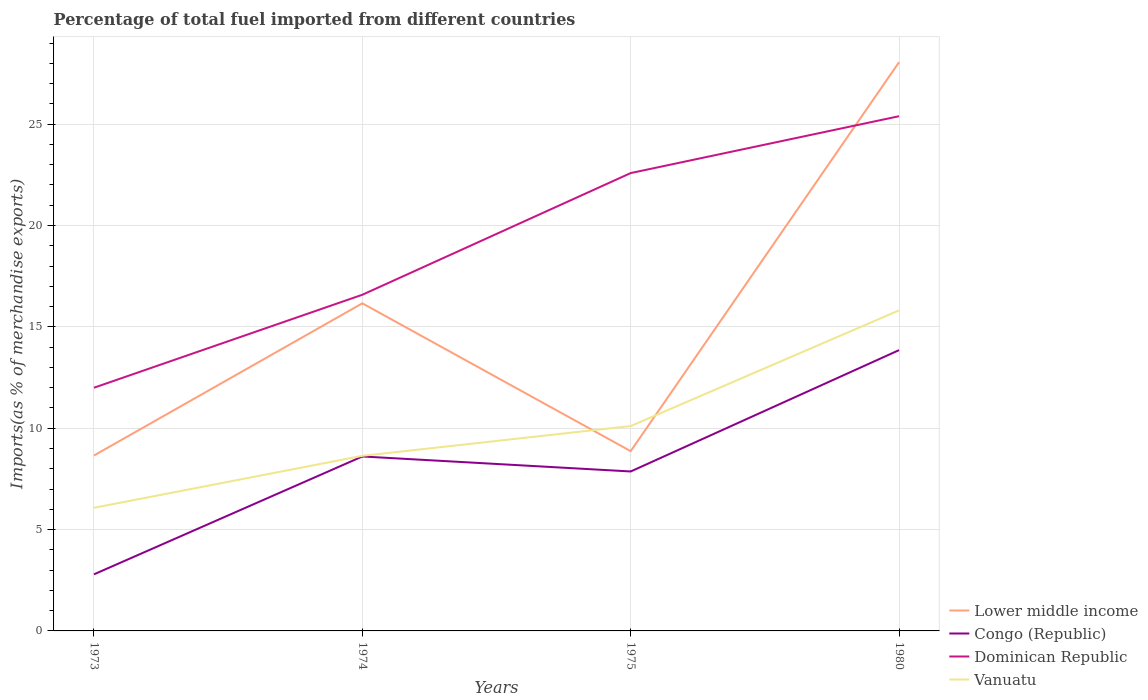How many different coloured lines are there?
Your answer should be very brief. 4. Is the number of lines equal to the number of legend labels?
Your response must be concise. Yes. Across all years, what is the maximum percentage of imports to different countries in Vanuatu?
Make the answer very short. 6.07. What is the total percentage of imports to different countries in Vanuatu in the graph?
Offer a terse response. -2.56. What is the difference between the highest and the second highest percentage of imports to different countries in Vanuatu?
Provide a succinct answer. 9.74. How many lines are there?
Provide a succinct answer. 4. What is the difference between two consecutive major ticks on the Y-axis?
Offer a very short reply. 5. Are the values on the major ticks of Y-axis written in scientific E-notation?
Provide a succinct answer. No. Does the graph contain any zero values?
Your response must be concise. No. Where does the legend appear in the graph?
Keep it short and to the point. Bottom right. How are the legend labels stacked?
Offer a very short reply. Vertical. What is the title of the graph?
Your answer should be very brief. Percentage of total fuel imported from different countries. Does "New Caledonia" appear as one of the legend labels in the graph?
Your response must be concise. No. What is the label or title of the X-axis?
Offer a very short reply. Years. What is the label or title of the Y-axis?
Make the answer very short. Imports(as % of merchandise exports). What is the Imports(as % of merchandise exports) of Lower middle income in 1973?
Provide a short and direct response. 8.65. What is the Imports(as % of merchandise exports) in Congo (Republic) in 1973?
Make the answer very short. 2.79. What is the Imports(as % of merchandise exports) of Dominican Republic in 1973?
Your answer should be very brief. 12. What is the Imports(as % of merchandise exports) of Vanuatu in 1973?
Keep it short and to the point. 6.07. What is the Imports(as % of merchandise exports) in Lower middle income in 1974?
Make the answer very short. 16.16. What is the Imports(as % of merchandise exports) in Congo (Republic) in 1974?
Your response must be concise. 8.61. What is the Imports(as % of merchandise exports) in Dominican Republic in 1974?
Offer a terse response. 16.58. What is the Imports(as % of merchandise exports) in Vanuatu in 1974?
Your answer should be very brief. 8.64. What is the Imports(as % of merchandise exports) of Lower middle income in 1975?
Ensure brevity in your answer.  8.87. What is the Imports(as % of merchandise exports) in Congo (Republic) in 1975?
Your answer should be very brief. 7.86. What is the Imports(as % of merchandise exports) of Dominican Republic in 1975?
Your answer should be compact. 22.58. What is the Imports(as % of merchandise exports) of Vanuatu in 1975?
Provide a short and direct response. 10.1. What is the Imports(as % of merchandise exports) in Lower middle income in 1980?
Offer a terse response. 28.05. What is the Imports(as % of merchandise exports) in Congo (Republic) in 1980?
Provide a short and direct response. 13.85. What is the Imports(as % of merchandise exports) in Dominican Republic in 1980?
Your answer should be very brief. 25.39. What is the Imports(as % of merchandise exports) in Vanuatu in 1980?
Offer a terse response. 15.81. Across all years, what is the maximum Imports(as % of merchandise exports) in Lower middle income?
Ensure brevity in your answer.  28.05. Across all years, what is the maximum Imports(as % of merchandise exports) in Congo (Republic)?
Make the answer very short. 13.85. Across all years, what is the maximum Imports(as % of merchandise exports) of Dominican Republic?
Offer a terse response. 25.39. Across all years, what is the maximum Imports(as % of merchandise exports) in Vanuatu?
Keep it short and to the point. 15.81. Across all years, what is the minimum Imports(as % of merchandise exports) of Lower middle income?
Offer a very short reply. 8.65. Across all years, what is the minimum Imports(as % of merchandise exports) in Congo (Republic)?
Offer a terse response. 2.79. Across all years, what is the minimum Imports(as % of merchandise exports) in Dominican Republic?
Provide a succinct answer. 12. Across all years, what is the minimum Imports(as % of merchandise exports) in Vanuatu?
Your answer should be very brief. 6.07. What is the total Imports(as % of merchandise exports) in Lower middle income in the graph?
Your response must be concise. 61.73. What is the total Imports(as % of merchandise exports) of Congo (Republic) in the graph?
Keep it short and to the point. 33.11. What is the total Imports(as % of merchandise exports) of Dominican Republic in the graph?
Your response must be concise. 76.55. What is the total Imports(as % of merchandise exports) in Vanuatu in the graph?
Make the answer very short. 40.63. What is the difference between the Imports(as % of merchandise exports) of Lower middle income in 1973 and that in 1974?
Provide a short and direct response. -7.51. What is the difference between the Imports(as % of merchandise exports) in Congo (Republic) in 1973 and that in 1974?
Your answer should be compact. -5.81. What is the difference between the Imports(as % of merchandise exports) of Dominican Republic in 1973 and that in 1974?
Provide a succinct answer. -4.59. What is the difference between the Imports(as % of merchandise exports) in Vanuatu in 1973 and that in 1974?
Offer a very short reply. -2.56. What is the difference between the Imports(as % of merchandise exports) of Lower middle income in 1973 and that in 1975?
Provide a succinct answer. -0.22. What is the difference between the Imports(as % of merchandise exports) of Congo (Republic) in 1973 and that in 1975?
Provide a short and direct response. -5.07. What is the difference between the Imports(as % of merchandise exports) in Dominican Republic in 1973 and that in 1975?
Keep it short and to the point. -10.59. What is the difference between the Imports(as % of merchandise exports) in Vanuatu in 1973 and that in 1975?
Provide a short and direct response. -4.03. What is the difference between the Imports(as % of merchandise exports) in Lower middle income in 1973 and that in 1980?
Your response must be concise. -19.4. What is the difference between the Imports(as % of merchandise exports) in Congo (Republic) in 1973 and that in 1980?
Ensure brevity in your answer.  -11.06. What is the difference between the Imports(as % of merchandise exports) in Dominican Republic in 1973 and that in 1980?
Keep it short and to the point. -13.39. What is the difference between the Imports(as % of merchandise exports) in Vanuatu in 1973 and that in 1980?
Provide a succinct answer. -9.74. What is the difference between the Imports(as % of merchandise exports) of Lower middle income in 1974 and that in 1975?
Offer a terse response. 7.29. What is the difference between the Imports(as % of merchandise exports) in Congo (Republic) in 1974 and that in 1975?
Your response must be concise. 0.74. What is the difference between the Imports(as % of merchandise exports) in Dominican Republic in 1974 and that in 1975?
Give a very brief answer. -6. What is the difference between the Imports(as % of merchandise exports) of Vanuatu in 1974 and that in 1975?
Ensure brevity in your answer.  -1.47. What is the difference between the Imports(as % of merchandise exports) in Lower middle income in 1974 and that in 1980?
Keep it short and to the point. -11.89. What is the difference between the Imports(as % of merchandise exports) in Congo (Republic) in 1974 and that in 1980?
Ensure brevity in your answer.  -5.25. What is the difference between the Imports(as % of merchandise exports) in Dominican Republic in 1974 and that in 1980?
Offer a terse response. -8.81. What is the difference between the Imports(as % of merchandise exports) of Vanuatu in 1974 and that in 1980?
Offer a very short reply. -7.17. What is the difference between the Imports(as % of merchandise exports) in Lower middle income in 1975 and that in 1980?
Your answer should be compact. -19.19. What is the difference between the Imports(as % of merchandise exports) in Congo (Republic) in 1975 and that in 1980?
Offer a terse response. -5.99. What is the difference between the Imports(as % of merchandise exports) in Dominican Republic in 1975 and that in 1980?
Offer a terse response. -2.81. What is the difference between the Imports(as % of merchandise exports) of Vanuatu in 1975 and that in 1980?
Offer a terse response. -5.71. What is the difference between the Imports(as % of merchandise exports) of Lower middle income in 1973 and the Imports(as % of merchandise exports) of Congo (Republic) in 1974?
Make the answer very short. 0.05. What is the difference between the Imports(as % of merchandise exports) in Lower middle income in 1973 and the Imports(as % of merchandise exports) in Dominican Republic in 1974?
Ensure brevity in your answer.  -7.93. What is the difference between the Imports(as % of merchandise exports) in Lower middle income in 1973 and the Imports(as % of merchandise exports) in Vanuatu in 1974?
Provide a succinct answer. 0.02. What is the difference between the Imports(as % of merchandise exports) in Congo (Republic) in 1973 and the Imports(as % of merchandise exports) in Dominican Republic in 1974?
Your answer should be compact. -13.79. What is the difference between the Imports(as % of merchandise exports) in Congo (Republic) in 1973 and the Imports(as % of merchandise exports) in Vanuatu in 1974?
Provide a short and direct response. -5.85. What is the difference between the Imports(as % of merchandise exports) of Dominican Republic in 1973 and the Imports(as % of merchandise exports) of Vanuatu in 1974?
Keep it short and to the point. 3.36. What is the difference between the Imports(as % of merchandise exports) in Lower middle income in 1973 and the Imports(as % of merchandise exports) in Congo (Republic) in 1975?
Provide a short and direct response. 0.79. What is the difference between the Imports(as % of merchandise exports) in Lower middle income in 1973 and the Imports(as % of merchandise exports) in Dominican Republic in 1975?
Ensure brevity in your answer.  -13.93. What is the difference between the Imports(as % of merchandise exports) in Lower middle income in 1973 and the Imports(as % of merchandise exports) in Vanuatu in 1975?
Your answer should be compact. -1.45. What is the difference between the Imports(as % of merchandise exports) in Congo (Republic) in 1973 and the Imports(as % of merchandise exports) in Dominican Republic in 1975?
Offer a very short reply. -19.79. What is the difference between the Imports(as % of merchandise exports) of Congo (Republic) in 1973 and the Imports(as % of merchandise exports) of Vanuatu in 1975?
Offer a terse response. -7.31. What is the difference between the Imports(as % of merchandise exports) of Dominican Republic in 1973 and the Imports(as % of merchandise exports) of Vanuatu in 1975?
Keep it short and to the point. 1.89. What is the difference between the Imports(as % of merchandise exports) in Lower middle income in 1973 and the Imports(as % of merchandise exports) in Congo (Republic) in 1980?
Your answer should be compact. -5.2. What is the difference between the Imports(as % of merchandise exports) of Lower middle income in 1973 and the Imports(as % of merchandise exports) of Dominican Republic in 1980?
Your response must be concise. -16.74. What is the difference between the Imports(as % of merchandise exports) in Lower middle income in 1973 and the Imports(as % of merchandise exports) in Vanuatu in 1980?
Keep it short and to the point. -7.16. What is the difference between the Imports(as % of merchandise exports) in Congo (Republic) in 1973 and the Imports(as % of merchandise exports) in Dominican Republic in 1980?
Make the answer very short. -22.6. What is the difference between the Imports(as % of merchandise exports) of Congo (Republic) in 1973 and the Imports(as % of merchandise exports) of Vanuatu in 1980?
Keep it short and to the point. -13.02. What is the difference between the Imports(as % of merchandise exports) in Dominican Republic in 1973 and the Imports(as % of merchandise exports) in Vanuatu in 1980?
Provide a succinct answer. -3.81. What is the difference between the Imports(as % of merchandise exports) of Lower middle income in 1974 and the Imports(as % of merchandise exports) of Congo (Republic) in 1975?
Offer a terse response. 8.29. What is the difference between the Imports(as % of merchandise exports) in Lower middle income in 1974 and the Imports(as % of merchandise exports) in Dominican Republic in 1975?
Your answer should be very brief. -6.42. What is the difference between the Imports(as % of merchandise exports) of Lower middle income in 1974 and the Imports(as % of merchandise exports) of Vanuatu in 1975?
Your answer should be compact. 6.06. What is the difference between the Imports(as % of merchandise exports) in Congo (Republic) in 1974 and the Imports(as % of merchandise exports) in Dominican Republic in 1975?
Make the answer very short. -13.98. What is the difference between the Imports(as % of merchandise exports) in Congo (Republic) in 1974 and the Imports(as % of merchandise exports) in Vanuatu in 1975?
Your answer should be compact. -1.5. What is the difference between the Imports(as % of merchandise exports) of Dominican Republic in 1974 and the Imports(as % of merchandise exports) of Vanuatu in 1975?
Ensure brevity in your answer.  6.48. What is the difference between the Imports(as % of merchandise exports) of Lower middle income in 1974 and the Imports(as % of merchandise exports) of Congo (Republic) in 1980?
Offer a very short reply. 2.31. What is the difference between the Imports(as % of merchandise exports) in Lower middle income in 1974 and the Imports(as % of merchandise exports) in Dominican Republic in 1980?
Your response must be concise. -9.23. What is the difference between the Imports(as % of merchandise exports) in Lower middle income in 1974 and the Imports(as % of merchandise exports) in Vanuatu in 1980?
Your answer should be compact. 0.35. What is the difference between the Imports(as % of merchandise exports) in Congo (Republic) in 1974 and the Imports(as % of merchandise exports) in Dominican Republic in 1980?
Offer a terse response. -16.78. What is the difference between the Imports(as % of merchandise exports) of Congo (Republic) in 1974 and the Imports(as % of merchandise exports) of Vanuatu in 1980?
Offer a terse response. -7.21. What is the difference between the Imports(as % of merchandise exports) in Dominican Republic in 1974 and the Imports(as % of merchandise exports) in Vanuatu in 1980?
Offer a terse response. 0.77. What is the difference between the Imports(as % of merchandise exports) of Lower middle income in 1975 and the Imports(as % of merchandise exports) of Congo (Republic) in 1980?
Your answer should be very brief. -4.98. What is the difference between the Imports(as % of merchandise exports) in Lower middle income in 1975 and the Imports(as % of merchandise exports) in Dominican Republic in 1980?
Offer a very short reply. -16.52. What is the difference between the Imports(as % of merchandise exports) of Lower middle income in 1975 and the Imports(as % of merchandise exports) of Vanuatu in 1980?
Ensure brevity in your answer.  -6.94. What is the difference between the Imports(as % of merchandise exports) in Congo (Republic) in 1975 and the Imports(as % of merchandise exports) in Dominican Republic in 1980?
Ensure brevity in your answer.  -17.52. What is the difference between the Imports(as % of merchandise exports) of Congo (Republic) in 1975 and the Imports(as % of merchandise exports) of Vanuatu in 1980?
Your response must be concise. -7.95. What is the difference between the Imports(as % of merchandise exports) of Dominican Republic in 1975 and the Imports(as % of merchandise exports) of Vanuatu in 1980?
Make the answer very short. 6.77. What is the average Imports(as % of merchandise exports) in Lower middle income per year?
Provide a short and direct response. 15.43. What is the average Imports(as % of merchandise exports) of Congo (Republic) per year?
Offer a very short reply. 8.28. What is the average Imports(as % of merchandise exports) of Dominican Republic per year?
Make the answer very short. 19.14. What is the average Imports(as % of merchandise exports) of Vanuatu per year?
Keep it short and to the point. 10.16. In the year 1973, what is the difference between the Imports(as % of merchandise exports) of Lower middle income and Imports(as % of merchandise exports) of Congo (Republic)?
Offer a very short reply. 5.86. In the year 1973, what is the difference between the Imports(as % of merchandise exports) in Lower middle income and Imports(as % of merchandise exports) in Dominican Republic?
Provide a succinct answer. -3.34. In the year 1973, what is the difference between the Imports(as % of merchandise exports) of Lower middle income and Imports(as % of merchandise exports) of Vanuatu?
Keep it short and to the point. 2.58. In the year 1973, what is the difference between the Imports(as % of merchandise exports) of Congo (Republic) and Imports(as % of merchandise exports) of Dominican Republic?
Your answer should be compact. -9.2. In the year 1973, what is the difference between the Imports(as % of merchandise exports) of Congo (Republic) and Imports(as % of merchandise exports) of Vanuatu?
Ensure brevity in your answer.  -3.28. In the year 1973, what is the difference between the Imports(as % of merchandise exports) in Dominican Republic and Imports(as % of merchandise exports) in Vanuatu?
Offer a very short reply. 5.92. In the year 1974, what is the difference between the Imports(as % of merchandise exports) in Lower middle income and Imports(as % of merchandise exports) in Congo (Republic)?
Keep it short and to the point. 7.55. In the year 1974, what is the difference between the Imports(as % of merchandise exports) of Lower middle income and Imports(as % of merchandise exports) of Dominican Republic?
Your answer should be very brief. -0.42. In the year 1974, what is the difference between the Imports(as % of merchandise exports) of Lower middle income and Imports(as % of merchandise exports) of Vanuatu?
Provide a short and direct response. 7.52. In the year 1974, what is the difference between the Imports(as % of merchandise exports) of Congo (Republic) and Imports(as % of merchandise exports) of Dominican Republic?
Offer a terse response. -7.98. In the year 1974, what is the difference between the Imports(as % of merchandise exports) in Congo (Republic) and Imports(as % of merchandise exports) in Vanuatu?
Your answer should be very brief. -0.03. In the year 1974, what is the difference between the Imports(as % of merchandise exports) of Dominican Republic and Imports(as % of merchandise exports) of Vanuatu?
Offer a terse response. 7.94. In the year 1975, what is the difference between the Imports(as % of merchandise exports) of Lower middle income and Imports(as % of merchandise exports) of Congo (Republic)?
Offer a terse response. 1. In the year 1975, what is the difference between the Imports(as % of merchandise exports) of Lower middle income and Imports(as % of merchandise exports) of Dominican Republic?
Make the answer very short. -13.72. In the year 1975, what is the difference between the Imports(as % of merchandise exports) of Lower middle income and Imports(as % of merchandise exports) of Vanuatu?
Give a very brief answer. -1.24. In the year 1975, what is the difference between the Imports(as % of merchandise exports) of Congo (Republic) and Imports(as % of merchandise exports) of Dominican Republic?
Keep it short and to the point. -14.72. In the year 1975, what is the difference between the Imports(as % of merchandise exports) in Congo (Republic) and Imports(as % of merchandise exports) in Vanuatu?
Keep it short and to the point. -2.24. In the year 1975, what is the difference between the Imports(as % of merchandise exports) of Dominican Republic and Imports(as % of merchandise exports) of Vanuatu?
Give a very brief answer. 12.48. In the year 1980, what is the difference between the Imports(as % of merchandise exports) of Lower middle income and Imports(as % of merchandise exports) of Congo (Republic)?
Provide a short and direct response. 14.2. In the year 1980, what is the difference between the Imports(as % of merchandise exports) of Lower middle income and Imports(as % of merchandise exports) of Dominican Republic?
Ensure brevity in your answer.  2.66. In the year 1980, what is the difference between the Imports(as % of merchandise exports) in Lower middle income and Imports(as % of merchandise exports) in Vanuatu?
Offer a terse response. 12.24. In the year 1980, what is the difference between the Imports(as % of merchandise exports) of Congo (Republic) and Imports(as % of merchandise exports) of Dominican Republic?
Your answer should be compact. -11.54. In the year 1980, what is the difference between the Imports(as % of merchandise exports) of Congo (Republic) and Imports(as % of merchandise exports) of Vanuatu?
Offer a very short reply. -1.96. In the year 1980, what is the difference between the Imports(as % of merchandise exports) in Dominican Republic and Imports(as % of merchandise exports) in Vanuatu?
Your response must be concise. 9.58. What is the ratio of the Imports(as % of merchandise exports) of Lower middle income in 1973 to that in 1974?
Your answer should be very brief. 0.54. What is the ratio of the Imports(as % of merchandise exports) in Congo (Republic) in 1973 to that in 1974?
Give a very brief answer. 0.32. What is the ratio of the Imports(as % of merchandise exports) in Dominican Republic in 1973 to that in 1974?
Keep it short and to the point. 0.72. What is the ratio of the Imports(as % of merchandise exports) in Vanuatu in 1973 to that in 1974?
Offer a terse response. 0.7. What is the ratio of the Imports(as % of merchandise exports) in Lower middle income in 1973 to that in 1975?
Keep it short and to the point. 0.98. What is the ratio of the Imports(as % of merchandise exports) of Congo (Republic) in 1973 to that in 1975?
Offer a very short reply. 0.35. What is the ratio of the Imports(as % of merchandise exports) of Dominican Republic in 1973 to that in 1975?
Offer a very short reply. 0.53. What is the ratio of the Imports(as % of merchandise exports) in Vanuatu in 1973 to that in 1975?
Keep it short and to the point. 0.6. What is the ratio of the Imports(as % of merchandise exports) in Lower middle income in 1973 to that in 1980?
Your answer should be compact. 0.31. What is the ratio of the Imports(as % of merchandise exports) in Congo (Republic) in 1973 to that in 1980?
Keep it short and to the point. 0.2. What is the ratio of the Imports(as % of merchandise exports) of Dominican Republic in 1973 to that in 1980?
Provide a succinct answer. 0.47. What is the ratio of the Imports(as % of merchandise exports) in Vanuatu in 1973 to that in 1980?
Ensure brevity in your answer.  0.38. What is the ratio of the Imports(as % of merchandise exports) in Lower middle income in 1974 to that in 1975?
Ensure brevity in your answer.  1.82. What is the ratio of the Imports(as % of merchandise exports) in Congo (Republic) in 1974 to that in 1975?
Make the answer very short. 1.09. What is the ratio of the Imports(as % of merchandise exports) in Dominican Republic in 1974 to that in 1975?
Your response must be concise. 0.73. What is the ratio of the Imports(as % of merchandise exports) of Vanuatu in 1974 to that in 1975?
Provide a short and direct response. 0.85. What is the ratio of the Imports(as % of merchandise exports) of Lower middle income in 1974 to that in 1980?
Your response must be concise. 0.58. What is the ratio of the Imports(as % of merchandise exports) of Congo (Republic) in 1974 to that in 1980?
Ensure brevity in your answer.  0.62. What is the ratio of the Imports(as % of merchandise exports) in Dominican Republic in 1974 to that in 1980?
Your answer should be very brief. 0.65. What is the ratio of the Imports(as % of merchandise exports) of Vanuatu in 1974 to that in 1980?
Ensure brevity in your answer.  0.55. What is the ratio of the Imports(as % of merchandise exports) of Lower middle income in 1975 to that in 1980?
Provide a succinct answer. 0.32. What is the ratio of the Imports(as % of merchandise exports) in Congo (Republic) in 1975 to that in 1980?
Provide a succinct answer. 0.57. What is the ratio of the Imports(as % of merchandise exports) in Dominican Republic in 1975 to that in 1980?
Make the answer very short. 0.89. What is the ratio of the Imports(as % of merchandise exports) in Vanuatu in 1975 to that in 1980?
Your response must be concise. 0.64. What is the difference between the highest and the second highest Imports(as % of merchandise exports) of Lower middle income?
Ensure brevity in your answer.  11.89. What is the difference between the highest and the second highest Imports(as % of merchandise exports) in Congo (Republic)?
Your response must be concise. 5.25. What is the difference between the highest and the second highest Imports(as % of merchandise exports) in Dominican Republic?
Provide a succinct answer. 2.81. What is the difference between the highest and the second highest Imports(as % of merchandise exports) in Vanuatu?
Provide a short and direct response. 5.71. What is the difference between the highest and the lowest Imports(as % of merchandise exports) in Lower middle income?
Offer a terse response. 19.4. What is the difference between the highest and the lowest Imports(as % of merchandise exports) in Congo (Republic)?
Your answer should be compact. 11.06. What is the difference between the highest and the lowest Imports(as % of merchandise exports) in Dominican Republic?
Your answer should be very brief. 13.39. What is the difference between the highest and the lowest Imports(as % of merchandise exports) in Vanuatu?
Provide a succinct answer. 9.74. 